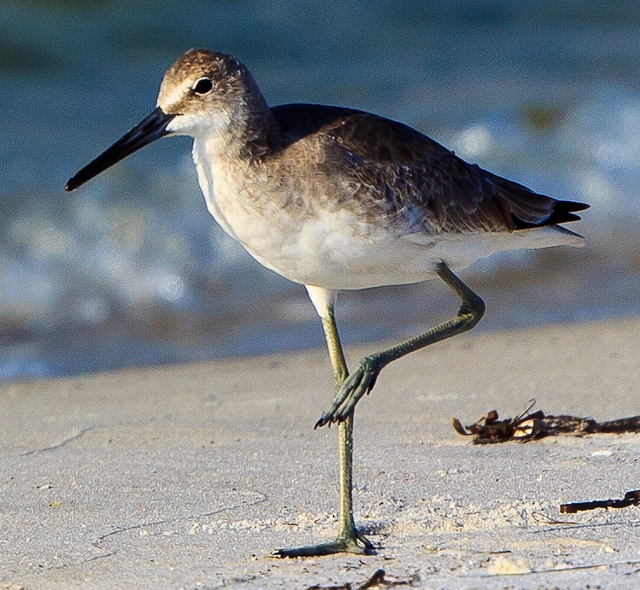Describe the objects in this image and their specific colors. I can see a bird in purple, black, darkgray, gray, and beige tones in this image. 